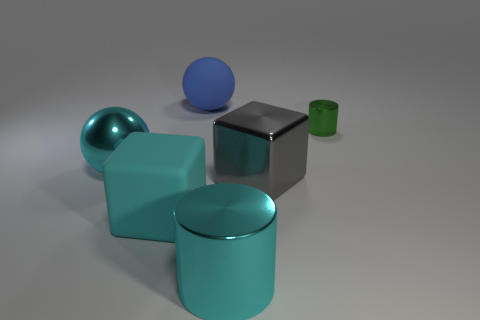There is a shiny cylinder that is the same color as the rubber block; what size is it?
Your answer should be very brief. Large. What number of spheres are green shiny things or large gray things?
Offer a terse response. 0. There is a metallic object that is behind the big metallic cube and to the left of the small shiny thing; what is its shape?
Your response must be concise. Sphere. Are there the same number of big blue matte spheres that are on the right side of the large gray cube and matte spheres in front of the small cylinder?
Offer a very short reply. Yes. How many things are gray matte cylinders or metal cylinders?
Keep it short and to the point. 2. What is the color of the shiny sphere that is the same size as the metal cube?
Offer a very short reply. Cyan. How many things are either spheres in front of the small green cylinder or balls that are to the left of the large blue thing?
Give a very brief answer. 1. Is the number of big blue spheres that are in front of the gray metal block the same as the number of large cyan metal things?
Give a very brief answer. No. There is a cylinder in front of the green metal thing; does it have the same size as the sphere that is behind the small shiny thing?
Offer a very short reply. Yes. What number of other things are there of the same size as the metal block?
Offer a very short reply. 4. 